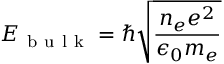Convert formula to latex. <formula><loc_0><loc_0><loc_500><loc_500>E _ { b u l k } = \hbar { \sqrt } { \frac { n _ { e } e ^ { 2 } } { \epsilon _ { 0 } m _ { e } } }</formula> 